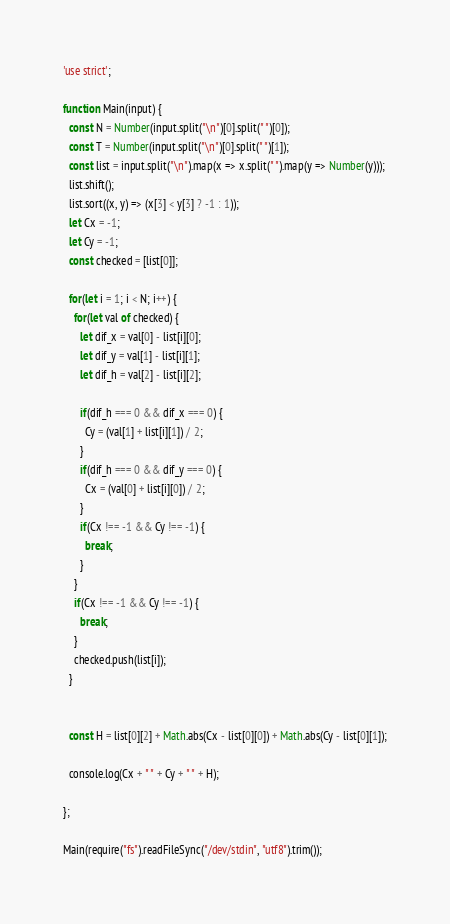<code> <loc_0><loc_0><loc_500><loc_500><_JavaScript_>'use strict';

function Main(input) {
  const N = Number(input.split("\n")[0].split(" ")[0]);
  const T = Number(input.split("\n")[0].split(" ")[1]);
  const list = input.split("\n").map(x => x.split(" ").map(y => Number(y)));
  list.shift();
  list.sort((x, y) => (x[3] < y[3] ? -1 : 1));
  let Cx = -1;
  let Cy = -1;
  const checked = [list[0]];

  for(let i = 1; i < N; i++) {
    for(let val of checked) {
      let dif_x = val[0] - list[i][0];
      let dif_y = val[1] - list[i][1];
      let dif_h = val[2] - list[i][2];

      if(dif_h === 0 && dif_x === 0) {
        Cy = (val[1] + list[i][1]) / 2;
      }
      if(dif_h === 0 && dif_y === 0) {
        Cx = (val[0] + list[i][0]) / 2;
      }
      if(Cx !== -1 && Cy !== -1) {
        break;
      }
    }
    if(Cx !== -1 && Cy !== -1) {
      break;
    }
    checked.push(list[i]);
  }
  

  const H = list[0][2] + Math.abs(Cx - list[0][0]) + Math.abs(Cy - list[0][1]);

  console.log(Cx + " " + Cy + " " + H);

};

Main(require("fs").readFileSync("/dev/stdin", "utf8").trim());
</code> 